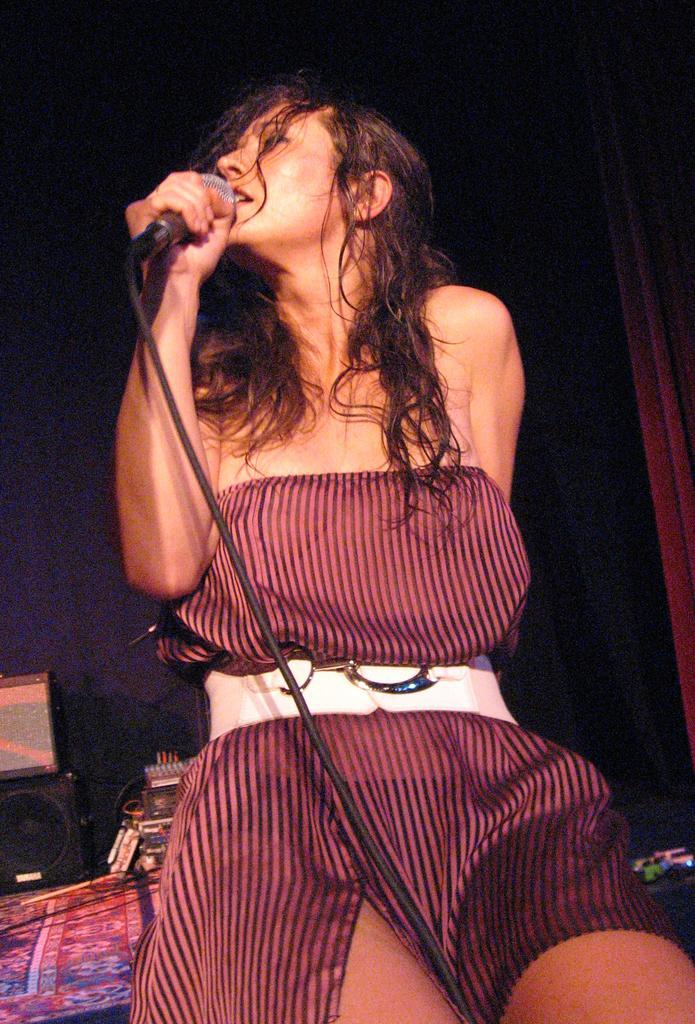Please provide a concise description of this image. In this image we can see a woman and the woman is holding a mic with wire. In the bottom left we can see few objects. The background of the image is dark. 